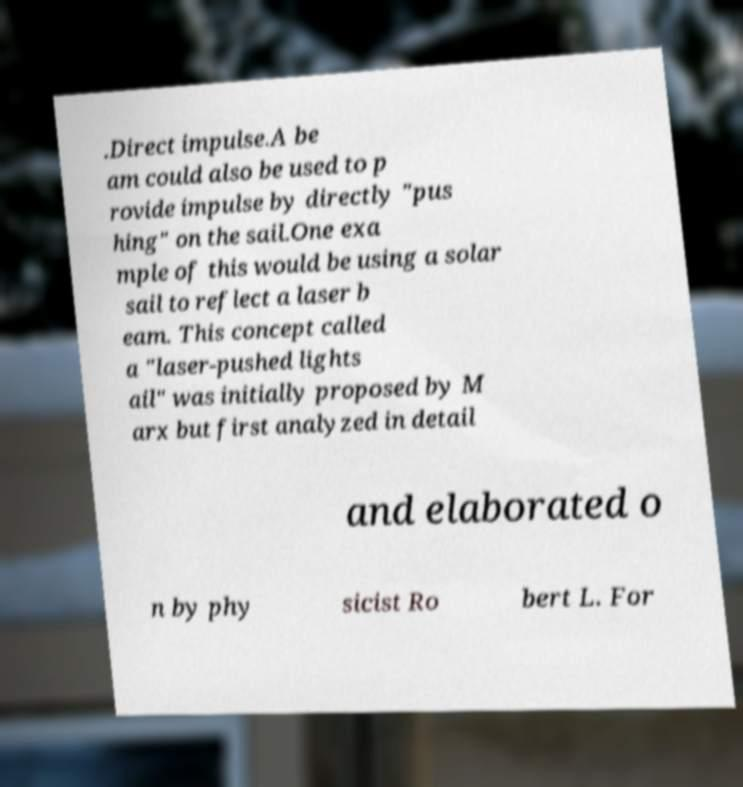Could you extract and type out the text from this image? .Direct impulse.A be am could also be used to p rovide impulse by directly "pus hing" on the sail.One exa mple of this would be using a solar sail to reflect a laser b eam. This concept called a "laser-pushed lights ail" was initially proposed by M arx but first analyzed in detail and elaborated o n by phy sicist Ro bert L. For 